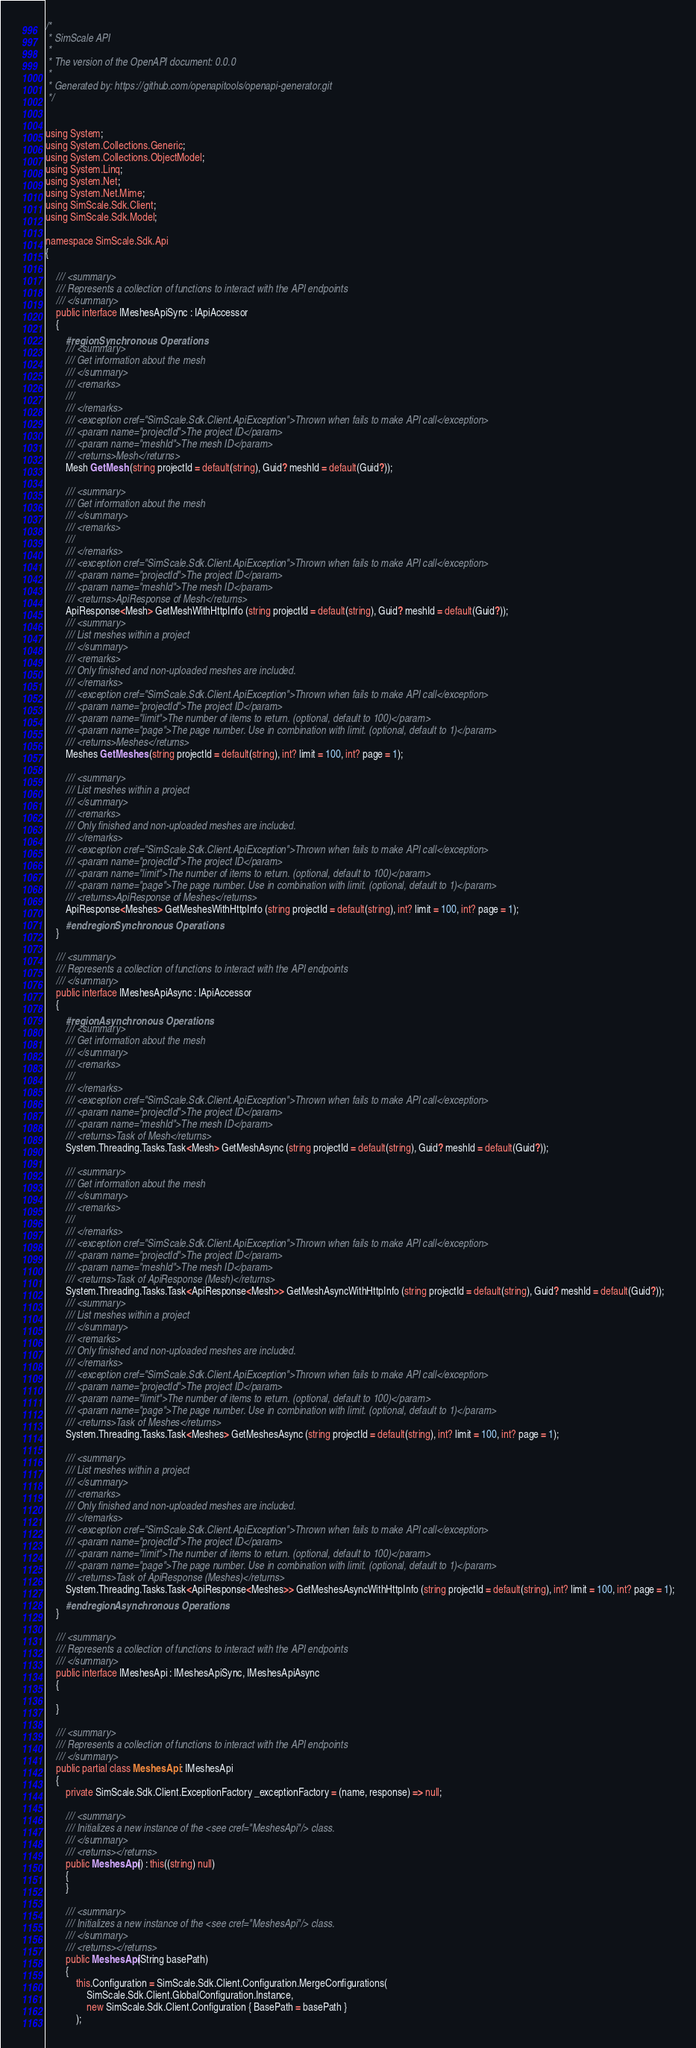<code> <loc_0><loc_0><loc_500><loc_500><_C#_>/* 
 * SimScale API
 *
 * The version of the OpenAPI document: 0.0.0
 * 
 * Generated by: https://github.com/openapitools/openapi-generator.git
 */


using System;
using System.Collections.Generic;
using System.Collections.ObjectModel;
using System.Linq;
using System.Net;
using System.Net.Mime;
using SimScale.Sdk.Client;
using SimScale.Sdk.Model;

namespace SimScale.Sdk.Api
{

    /// <summary>
    /// Represents a collection of functions to interact with the API endpoints
    /// </summary>
    public interface IMeshesApiSync : IApiAccessor
    {
        #region Synchronous Operations
        /// <summary>
        /// Get information about the mesh
        /// </summary>
        /// <remarks>
        /// 
        /// </remarks>
        /// <exception cref="SimScale.Sdk.Client.ApiException">Thrown when fails to make API call</exception>
        /// <param name="projectId">The project ID</param>
        /// <param name="meshId">The mesh ID</param>
        /// <returns>Mesh</returns>
        Mesh GetMesh (string projectId = default(string), Guid? meshId = default(Guid?));

        /// <summary>
        /// Get information about the mesh
        /// </summary>
        /// <remarks>
        /// 
        /// </remarks>
        /// <exception cref="SimScale.Sdk.Client.ApiException">Thrown when fails to make API call</exception>
        /// <param name="projectId">The project ID</param>
        /// <param name="meshId">The mesh ID</param>
        /// <returns>ApiResponse of Mesh</returns>
        ApiResponse<Mesh> GetMeshWithHttpInfo (string projectId = default(string), Guid? meshId = default(Guid?));
        /// <summary>
        /// List meshes within a project
        /// </summary>
        /// <remarks>
        /// Only finished and non-uploaded meshes are included.
        /// </remarks>
        /// <exception cref="SimScale.Sdk.Client.ApiException">Thrown when fails to make API call</exception>
        /// <param name="projectId">The project ID</param>
        /// <param name="limit">The number of items to return. (optional, default to 100)</param>
        /// <param name="page">The page number. Use in combination with limit. (optional, default to 1)</param>
        /// <returns>Meshes</returns>
        Meshes GetMeshes (string projectId = default(string), int? limit = 100, int? page = 1);

        /// <summary>
        /// List meshes within a project
        /// </summary>
        /// <remarks>
        /// Only finished and non-uploaded meshes are included.
        /// </remarks>
        /// <exception cref="SimScale.Sdk.Client.ApiException">Thrown when fails to make API call</exception>
        /// <param name="projectId">The project ID</param>
        /// <param name="limit">The number of items to return. (optional, default to 100)</param>
        /// <param name="page">The page number. Use in combination with limit. (optional, default to 1)</param>
        /// <returns>ApiResponse of Meshes</returns>
        ApiResponse<Meshes> GetMeshesWithHttpInfo (string projectId = default(string), int? limit = 100, int? page = 1);
        #endregion Synchronous Operations
    }

    /// <summary>
    /// Represents a collection of functions to interact with the API endpoints
    /// </summary>
    public interface IMeshesApiAsync : IApiAccessor
    {
        #region Asynchronous Operations
        /// <summary>
        /// Get information about the mesh
        /// </summary>
        /// <remarks>
        /// 
        /// </remarks>
        /// <exception cref="SimScale.Sdk.Client.ApiException">Thrown when fails to make API call</exception>
        /// <param name="projectId">The project ID</param>
        /// <param name="meshId">The mesh ID</param>
        /// <returns>Task of Mesh</returns>
        System.Threading.Tasks.Task<Mesh> GetMeshAsync (string projectId = default(string), Guid? meshId = default(Guid?));

        /// <summary>
        /// Get information about the mesh
        /// </summary>
        /// <remarks>
        /// 
        /// </remarks>
        /// <exception cref="SimScale.Sdk.Client.ApiException">Thrown when fails to make API call</exception>
        /// <param name="projectId">The project ID</param>
        /// <param name="meshId">The mesh ID</param>
        /// <returns>Task of ApiResponse (Mesh)</returns>
        System.Threading.Tasks.Task<ApiResponse<Mesh>> GetMeshAsyncWithHttpInfo (string projectId = default(string), Guid? meshId = default(Guid?));
        /// <summary>
        /// List meshes within a project
        /// </summary>
        /// <remarks>
        /// Only finished and non-uploaded meshes are included.
        /// </remarks>
        /// <exception cref="SimScale.Sdk.Client.ApiException">Thrown when fails to make API call</exception>
        /// <param name="projectId">The project ID</param>
        /// <param name="limit">The number of items to return. (optional, default to 100)</param>
        /// <param name="page">The page number. Use in combination with limit. (optional, default to 1)</param>
        /// <returns>Task of Meshes</returns>
        System.Threading.Tasks.Task<Meshes> GetMeshesAsync (string projectId = default(string), int? limit = 100, int? page = 1);

        /// <summary>
        /// List meshes within a project
        /// </summary>
        /// <remarks>
        /// Only finished and non-uploaded meshes are included.
        /// </remarks>
        /// <exception cref="SimScale.Sdk.Client.ApiException">Thrown when fails to make API call</exception>
        /// <param name="projectId">The project ID</param>
        /// <param name="limit">The number of items to return. (optional, default to 100)</param>
        /// <param name="page">The page number. Use in combination with limit. (optional, default to 1)</param>
        /// <returns>Task of ApiResponse (Meshes)</returns>
        System.Threading.Tasks.Task<ApiResponse<Meshes>> GetMeshesAsyncWithHttpInfo (string projectId = default(string), int? limit = 100, int? page = 1);
        #endregion Asynchronous Operations
    }

    /// <summary>
    /// Represents a collection of functions to interact with the API endpoints
    /// </summary>
    public interface IMeshesApi : IMeshesApiSync, IMeshesApiAsync
    {

    }

    /// <summary>
    /// Represents a collection of functions to interact with the API endpoints
    /// </summary>
    public partial class MeshesApi : IMeshesApi
    {
        private SimScale.Sdk.Client.ExceptionFactory _exceptionFactory = (name, response) => null;

        /// <summary>
        /// Initializes a new instance of the <see cref="MeshesApi"/> class.
        /// </summary>
        /// <returns></returns>
        public MeshesApi() : this((string) null)
        {
        }

        /// <summary>
        /// Initializes a new instance of the <see cref="MeshesApi"/> class.
        /// </summary>
        /// <returns></returns>
        public MeshesApi(String basePath)
        {
            this.Configuration = SimScale.Sdk.Client.Configuration.MergeConfigurations(
                SimScale.Sdk.Client.GlobalConfiguration.Instance,
                new SimScale.Sdk.Client.Configuration { BasePath = basePath }
            );</code> 